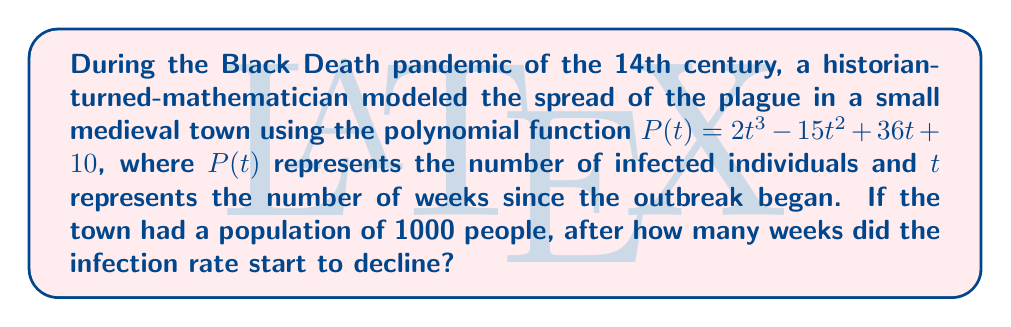Help me with this question. To find when the infection rate starts to decline, we need to determine the maximum point of the polynomial function. This occurs when the derivative of the function equals zero.

1. Find the derivative of $P(t)$:
   $$P'(t) = 6t^2 - 30t + 36$$

2. Set the derivative equal to zero and solve for t:
   $$6t^2 - 30t + 36 = 0$$

3. This is a quadratic equation. We can solve it using the quadratic formula:
   $$t = \frac{-b \pm \sqrt{b^2 - 4ac}}{2a}$$
   Where $a = 6$, $b = -30$, and $c = 36$

4. Plugging in the values:
   $$t = \frac{30 \pm \sqrt{(-30)^2 - 4(6)(36)}}{2(6)}$$
   $$t = \frac{30 \pm \sqrt{900 - 864}}{12}$$
   $$t = \frac{30 \pm \sqrt{36}}{12}$$
   $$t = \frac{30 \pm 6}{12}$$

5. This gives us two solutions:
   $$t = \frac{36}{12} = 3$$ or $$t = \frac{24}{12} = 2$$

6. The larger value (3) represents the maximum point, after which the infection rate starts to decline.

Therefore, the infection rate starts to decline after 3 weeks.
Answer: 3 weeks 